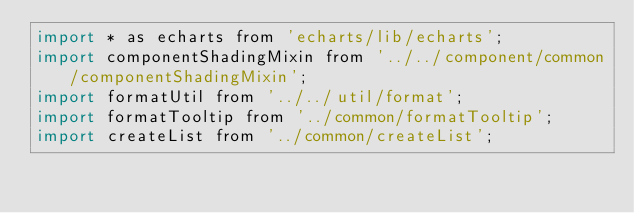<code> <loc_0><loc_0><loc_500><loc_500><_JavaScript_>import * as echarts from 'echarts/lib/echarts';
import componentShadingMixin from '../../component/common/componentShadingMixin';
import formatUtil from '../../util/format';
import formatTooltip from '../common/formatTooltip';
import createList from '../common/createList';
</code> 